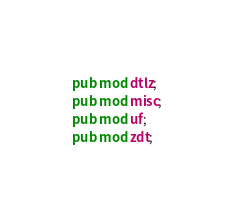<code> <loc_0><loc_0><loc_500><loc_500><_Rust_>pub mod dtlz;
pub mod misc;
pub mod uf;
pub mod zdt;
</code> 